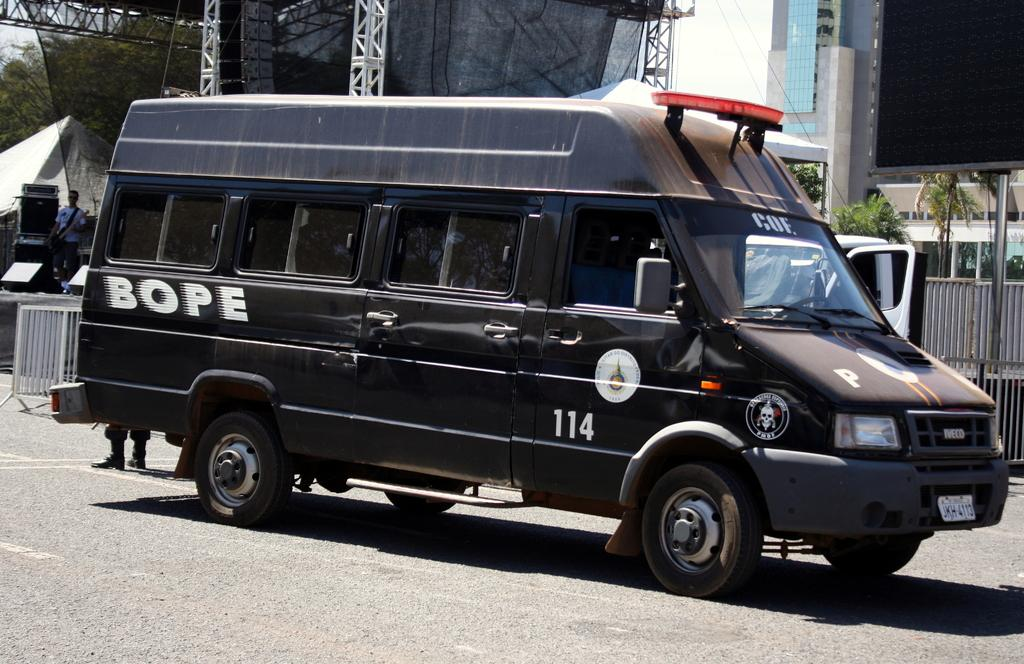<image>
Render a clear and concise summary of the photo. A BOPE vehicle in black with the number 114 on it 